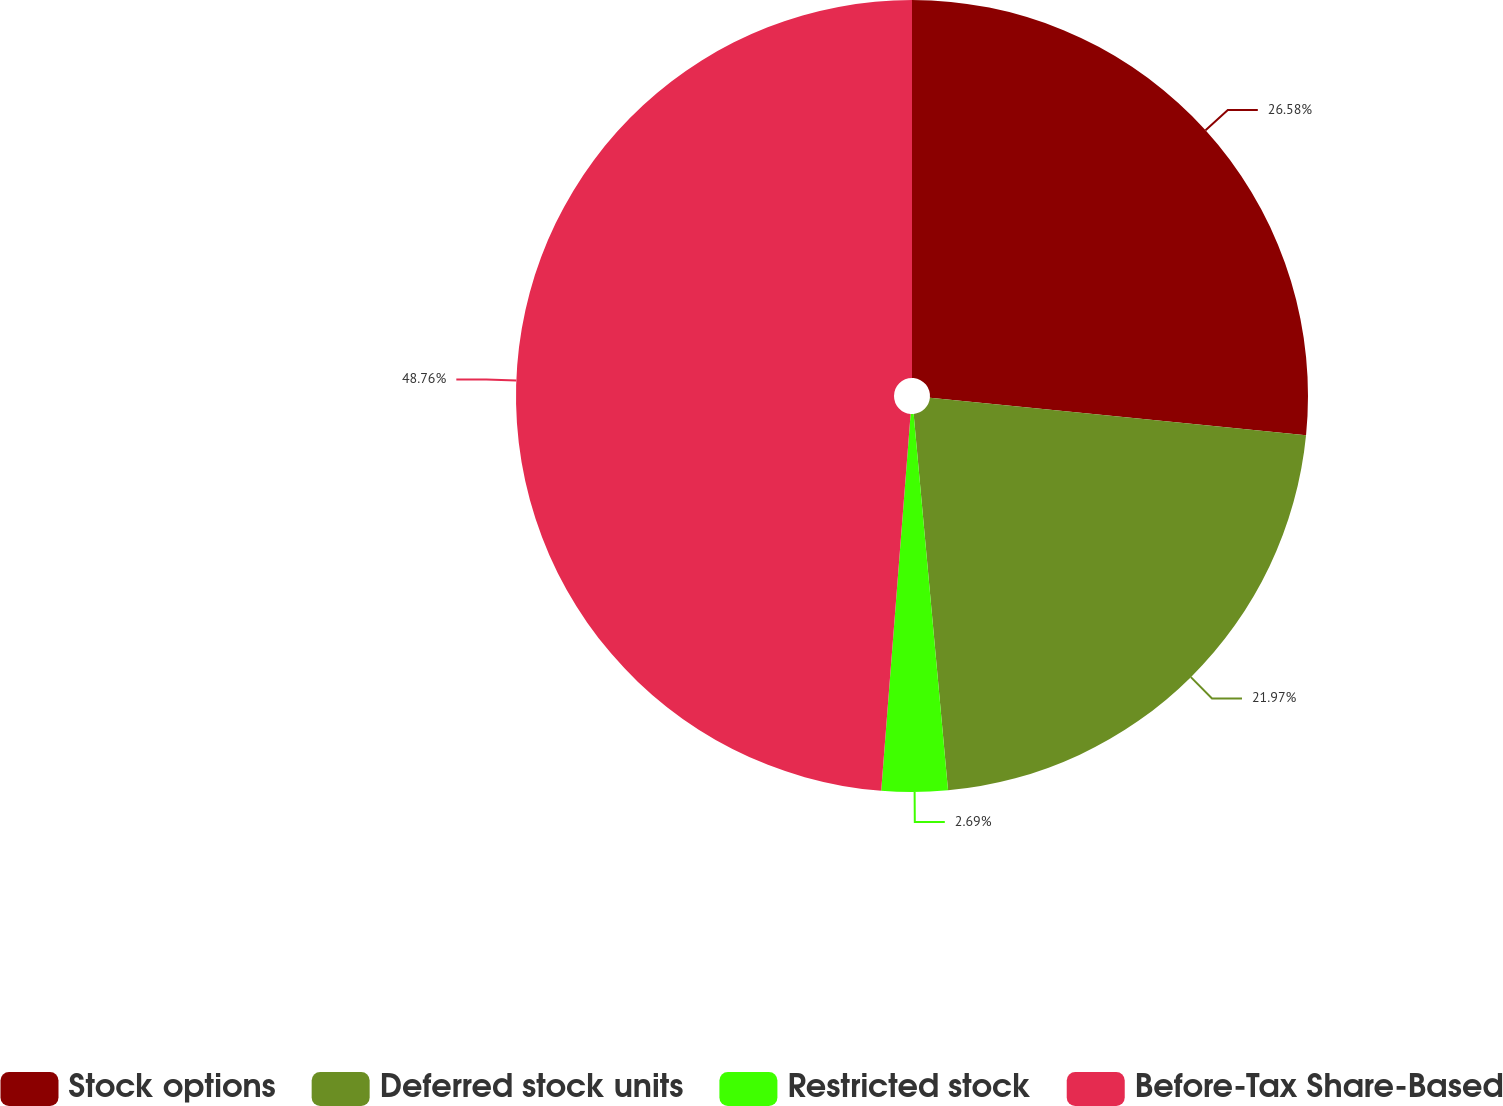<chart> <loc_0><loc_0><loc_500><loc_500><pie_chart><fcel>Stock options<fcel>Deferred stock units<fcel>Restricted stock<fcel>Before-Tax Share-Based<nl><fcel>26.58%<fcel>21.97%<fcel>2.69%<fcel>48.76%<nl></chart> 